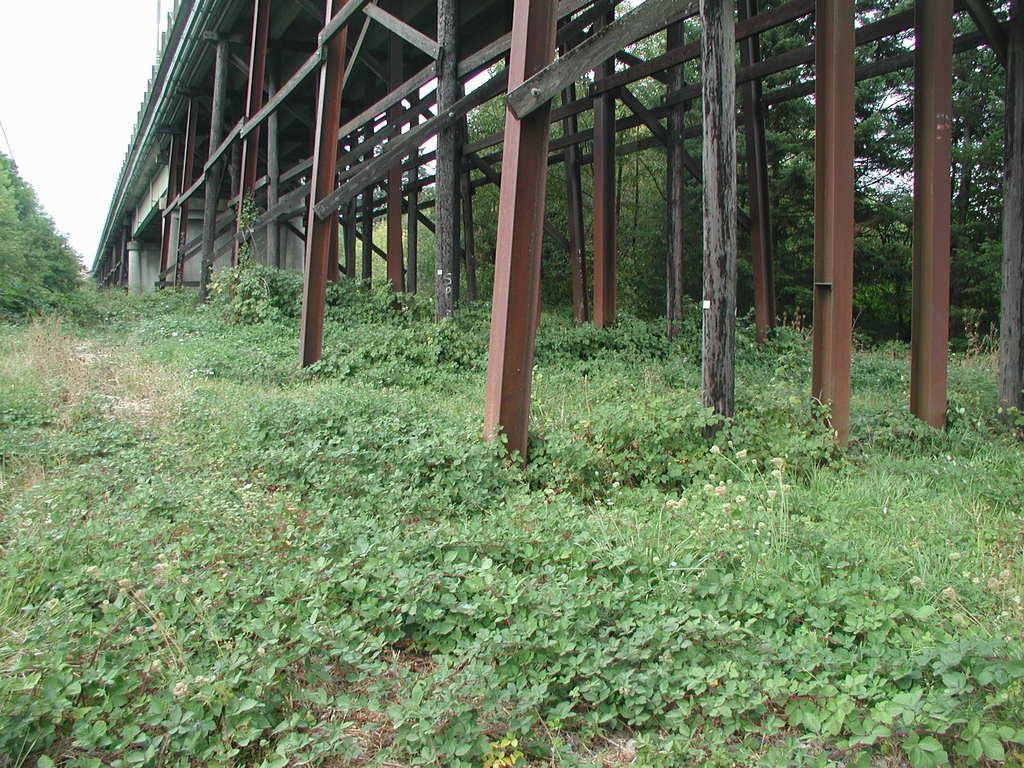Could you give a brief overview of what you see in this image? Here we can see plants, poles, and trees. In the background there is sky. 